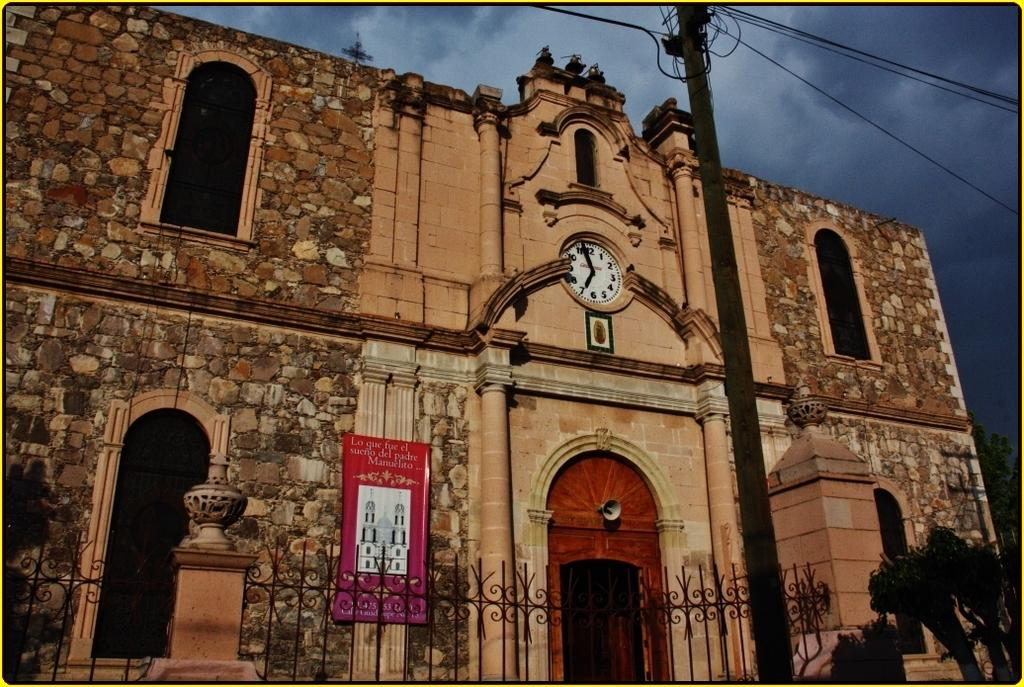<image>
Render a clear and concise summary of the photo. Front of a church which has a sign that says "Manuelito". 